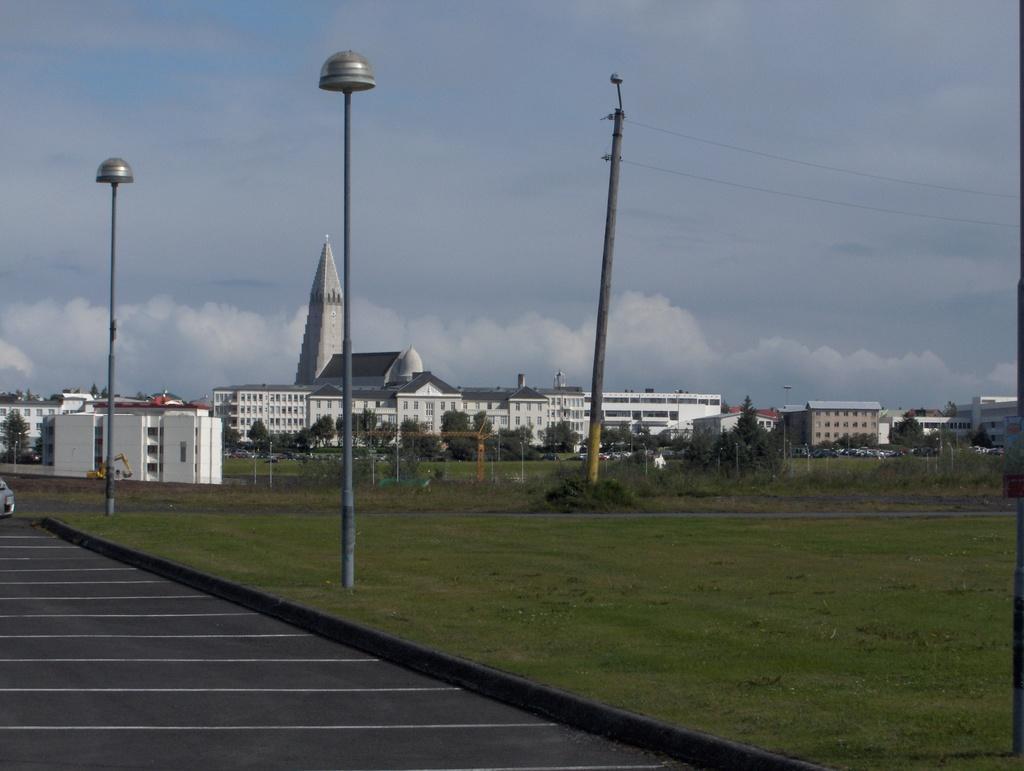How would you summarize this image in a sentence or two? In this picture we can see there are two poles and an electric poles with cables. Behind the poles there is fence, buildings, trees and the sky. On the left side of the poles there is a vehicle on the road. 